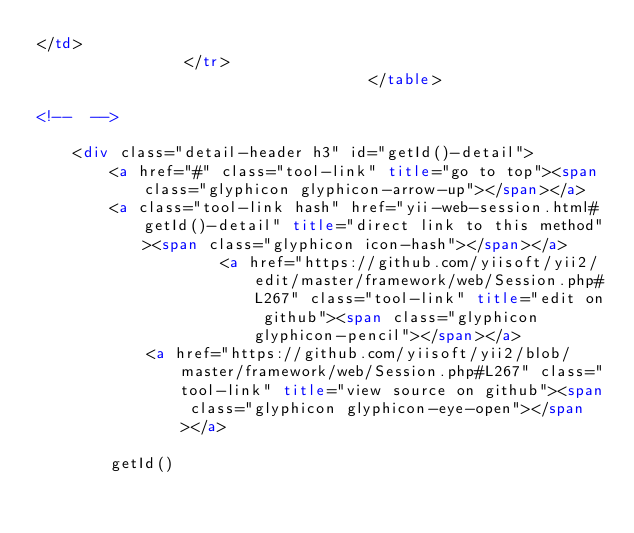<code> <loc_0><loc_0><loc_500><loc_500><_HTML_></td>
                </tr>
                                    </table>

<!--	-->

    <div class="detail-header h3" id="getId()-detail">
        <a href="#" class="tool-link" title="go to top"><span class="glyphicon glyphicon-arrow-up"></span></a>
        <a class="tool-link hash" href="yii-web-session.html#getId()-detail" title="direct link to this method"><span class="glyphicon icon-hash"></span></a>
                    <a href="https://github.com/yiisoft/yii2/edit/master/framework/web/Session.php#L267" class="tool-link" title="edit on github"><span class="glyphicon glyphicon-pencil"></span></a>
            <a href="https://github.com/yiisoft/yii2/blob/master/framework/web/Session.php#L267" class="tool-link" title="view source on github"><span class="glyphicon glyphicon-eye-open"></span></a>
        
        getId()</code> 